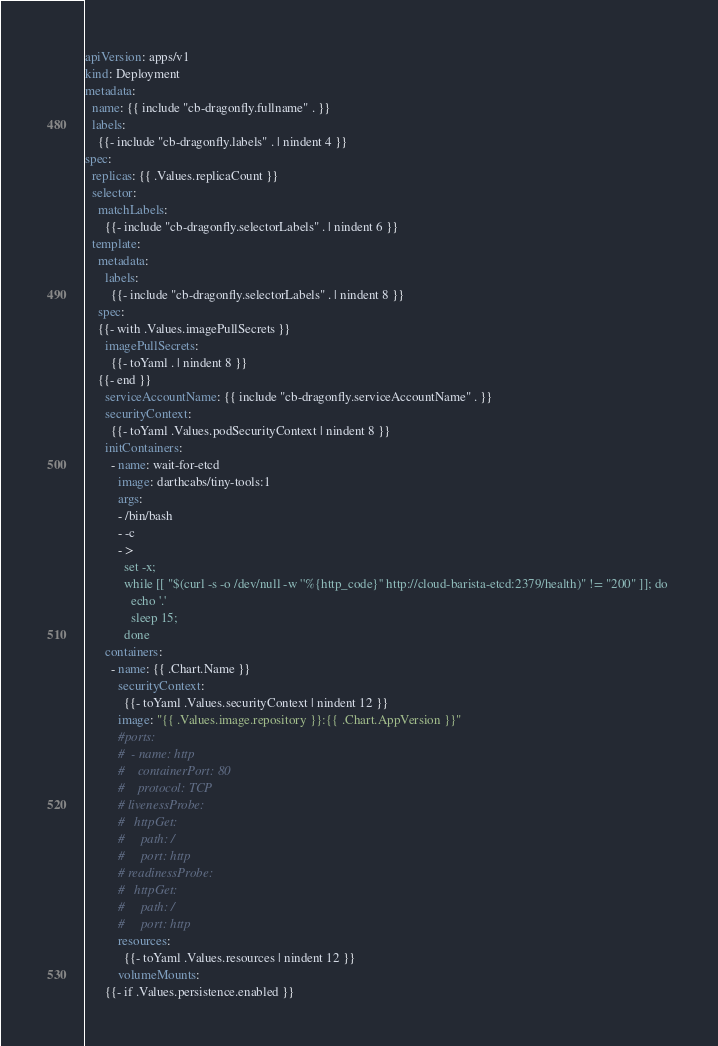Convert code to text. <code><loc_0><loc_0><loc_500><loc_500><_YAML_>apiVersion: apps/v1
kind: Deployment
metadata:
  name: {{ include "cb-dragonfly.fullname" . }}
  labels:
    {{- include "cb-dragonfly.labels" . | nindent 4 }}
spec:
  replicas: {{ .Values.replicaCount }}
  selector:
    matchLabels:
      {{- include "cb-dragonfly.selectorLabels" . | nindent 6 }}
  template:
    metadata:
      labels:
        {{- include "cb-dragonfly.selectorLabels" . | nindent 8 }}
    spec:
    {{- with .Values.imagePullSecrets }}
      imagePullSecrets:
        {{- toYaml . | nindent 8 }}
    {{- end }}
      serviceAccountName: {{ include "cb-dragonfly.serviceAccountName" . }}
      securityContext:
        {{- toYaml .Values.podSecurityContext | nindent 8 }}
      initContainers:
        - name: wait-for-etcd
          image: darthcabs/tiny-tools:1
          args:
          - /bin/bash
          - -c
          - >
            set -x;
            while [[ "$(curl -s -o /dev/null -w ''%{http_code}'' http://cloud-barista-etcd:2379/health)" != "200" ]]; do 
              echo '.'
              sleep 15;
            done
      containers:
        - name: {{ .Chart.Name }}
          securityContext:
            {{- toYaml .Values.securityContext | nindent 12 }}
          image: "{{ .Values.image.repository }}:{{ .Chart.AppVersion }}"
          #ports:
          #  - name: http
          #    containerPort: 80
          #    protocol: TCP
          # livenessProbe:
          #   httpGet:
          #     path: /
          #     port: http
          # readinessProbe:
          #   httpGet:
          #     path: /
          #     port: http
          resources:
            {{- toYaml .Values.resources | nindent 12 }}
          volumeMounts:
      {{- if .Values.persistence.enabled }}</code> 